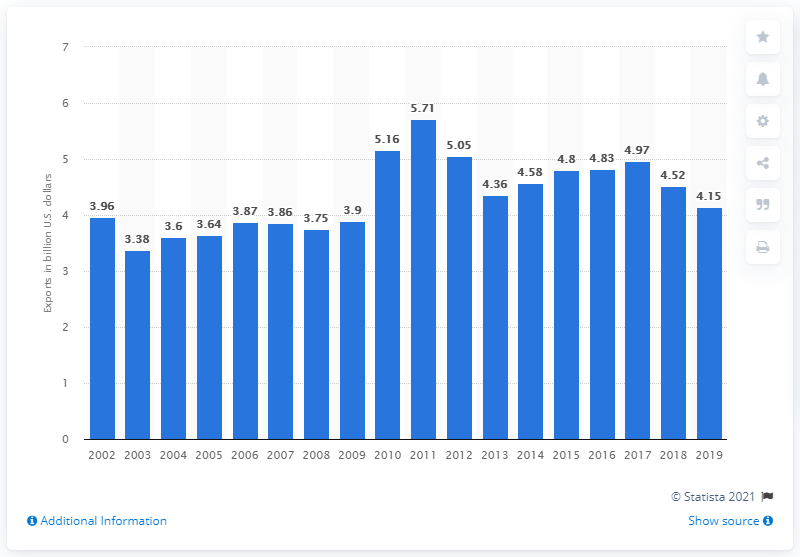Give some essential details in this illustration. The value of U.S. exports of television, VCR, and video equipment from 2002 to 2019 was $4.15 billion. 